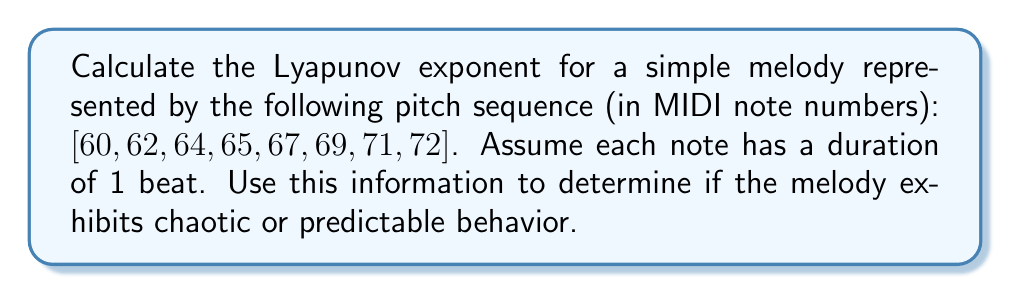Show me your answer to this math problem. To calculate the Lyapunov exponent for this melody:

1. Convert MIDI note numbers to frequencies:
   $f = 440 \times 2^{(n-69)/12}$, where n is the MIDI note number.
   
   [261.63, 293.66, 329.63, 349.23, 392.00, 440.00, 493.88, 523.25] Hz

2. Calculate the differences between consecutive frequencies:
   $\Delta f_i = f_{i+1} - f_i$
   
   [32.03, 35.97, 19.60, 42.77, 48.00, 53.88, 29.37] Hz

3. Compute the logarithm of the absolute values of these differences:
   $\ln(|\Delta f_i|)$
   
   [3.47, 3.58, 2.98, 3.76, 3.87, 3.99, 3.38]

4. Calculate the average of these logarithms:
   $\lambda = \frac{1}{N-1} \sum_{i=1}^{N-1} \ln(|\Delta f_i|)$
   
   $\lambda = \frac{1}{7} (3.47 + 3.58 + 2.98 + 3.76 + 3.87 + 3.99 + 3.38)$
   $\lambda \approx 3.58$

5. Interpret the result:
   - If $\lambda > 0$, the system exhibits chaotic behavior.
   - If $\lambda < 0$, the system is stable and predictable.
   - If $\lambda = 0$, the system is in a steady state.

Since $\lambda \approx 3.58 > 0$, the melody exhibits chaotic behavior.
Answer: $\lambda \approx 3.58$ (chaotic) 